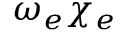<formula> <loc_0><loc_0><loc_500><loc_500>\omega _ { e } \chi _ { e }</formula> 